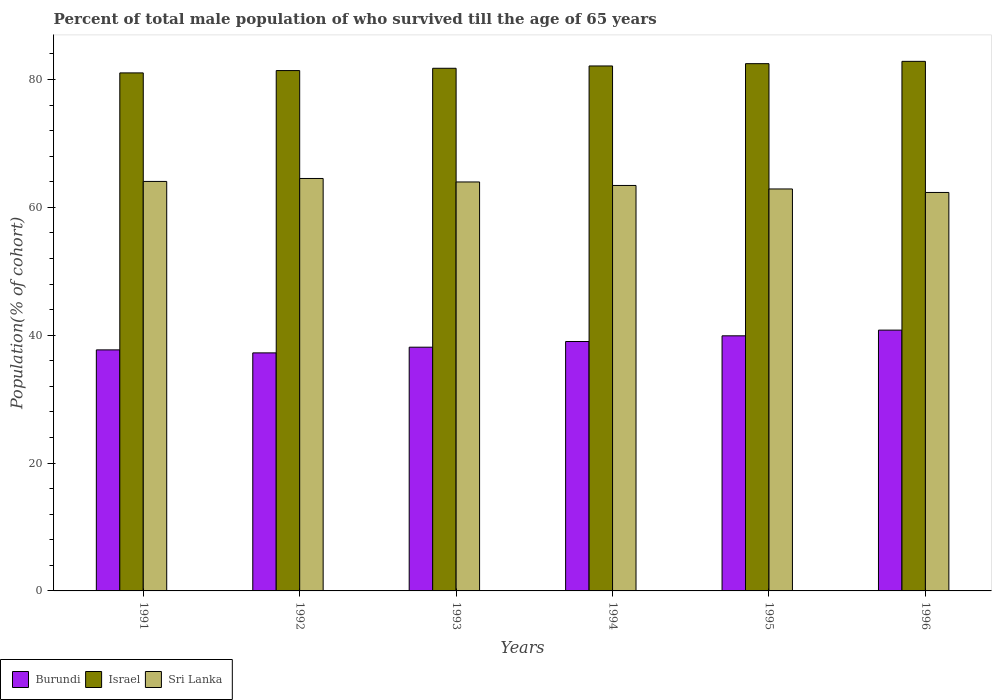How many different coloured bars are there?
Provide a succinct answer. 3. How many groups of bars are there?
Offer a terse response. 6. Are the number of bars per tick equal to the number of legend labels?
Offer a terse response. Yes. How many bars are there on the 4th tick from the left?
Your answer should be very brief. 3. How many bars are there on the 1st tick from the right?
Provide a succinct answer. 3. What is the label of the 1st group of bars from the left?
Keep it short and to the point. 1991. What is the percentage of total male population who survived till the age of 65 years in Israel in 1993?
Give a very brief answer. 81.76. Across all years, what is the maximum percentage of total male population who survived till the age of 65 years in Sri Lanka?
Provide a succinct answer. 64.52. Across all years, what is the minimum percentage of total male population who survived till the age of 65 years in Burundi?
Make the answer very short. 37.24. In which year was the percentage of total male population who survived till the age of 65 years in Israel maximum?
Your answer should be very brief. 1996. What is the total percentage of total male population who survived till the age of 65 years in Sri Lanka in the graph?
Make the answer very short. 381.21. What is the difference between the percentage of total male population who survived till the age of 65 years in Israel in 1993 and that in 1994?
Offer a terse response. -0.36. What is the difference between the percentage of total male population who survived till the age of 65 years in Israel in 1993 and the percentage of total male population who survived till the age of 65 years in Burundi in 1991?
Give a very brief answer. 44.06. What is the average percentage of total male population who survived till the age of 65 years in Israel per year?
Ensure brevity in your answer.  81.94. In the year 1995, what is the difference between the percentage of total male population who survived till the age of 65 years in Israel and percentage of total male population who survived till the age of 65 years in Burundi?
Give a very brief answer. 42.58. What is the ratio of the percentage of total male population who survived till the age of 65 years in Israel in 1995 to that in 1996?
Keep it short and to the point. 1. Is the percentage of total male population who survived till the age of 65 years in Sri Lanka in 1992 less than that in 1994?
Make the answer very short. No. Is the difference between the percentage of total male population who survived till the age of 65 years in Israel in 1991 and 1996 greater than the difference between the percentage of total male population who survived till the age of 65 years in Burundi in 1991 and 1996?
Make the answer very short. Yes. What is the difference between the highest and the second highest percentage of total male population who survived till the age of 65 years in Burundi?
Offer a very short reply. 0.89. What is the difference between the highest and the lowest percentage of total male population who survived till the age of 65 years in Burundi?
Offer a terse response. 3.56. In how many years, is the percentage of total male population who survived till the age of 65 years in Israel greater than the average percentage of total male population who survived till the age of 65 years in Israel taken over all years?
Keep it short and to the point. 3. Is the sum of the percentage of total male population who survived till the age of 65 years in Burundi in 1991 and 1995 greater than the maximum percentage of total male population who survived till the age of 65 years in Sri Lanka across all years?
Your response must be concise. Yes. What does the 1st bar from the left in 1996 represents?
Provide a succinct answer. Burundi. What does the 3rd bar from the right in 1994 represents?
Your answer should be compact. Burundi. Is it the case that in every year, the sum of the percentage of total male population who survived till the age of 65 years in Burundi and percentage of total male population who survived till the age of 65 years in Sri Lanka is greater than the percentage of total male population who survived till the age of 65 years in Israel?
Your response must be concise. Yes. What is the title of the graph?
Keep it short and to the point. Percent of total male population of who survived till the age of 65 years. What is the label or title of the Y-axis?
Your answer should be very brief. Population(% of cohort). What is the Population(% of cohort) of Burundi in 1991?
Keep it short and to the point. 37.71. What is the Population(% of cohort) in Israel in 1991?
Make the answer very short. 81.04. What is the Population(% of cohort) in Sri Lanka in 1991?
Offer a terse response. 64.06. What is the Population(% of cohort) in Burundi in 1992?
Offer a very short reply. 37.24. What is the Population(% of cohort) in Israel in 1992?
Your response must be concise. 81.4. What is the Population(% of cohort) in Sri Lanka in 1992?
Your answer should be compact. 64.52. What is the Population(% of cohort) of Burundi in 1993?
Offer a very short reply. 38.13. What is the Population(% of cohort) of Israel in 1993?
Ensure brevity in your answer.  81.76. What is the Population(% of cohort) in Sri Lanka in 1993?
Ensure brevity in your answer.  63.98. What is the Population(% of cohort) in Burundi in 1994?
Provide a short and direct response. 39.02. What is the Population(% of cohort) in Israel in 1994?
Provide a short and direct response. 82.12. What is the Population(% of cohort) of Sri Lanka in 1994?
Make the answer very short. 63.43. What is the Population(% of cohort) in Burundi in 1995?
Your answer should be compact. 39.91. What is the Population(% of cohort) in Israel in 1995?
Your answer should be very brief. 82.49. What is the Population(% of cohort) in Sri Lanka in 1995?
Provide a short and direct response. 62.88. What is the Population(% of cohort) of Burundi in 1996?
Provide a succinct answer. 40.8. What is the Population(% of cohort) in Israel in 1996?
Offer a terse response. 82.85. What is the Population(% of cohort) in Sri Lanka in 1996?
Your answer should be compact. 62.34. Across all years, what is the maximum Population(% of cohort) of Burundi?
Offer a very short reply. 40.8. Across all years, what is the maximum Population(% of cohort) in Israel?
Your answer should be compact. 82.85. Across all years, what is the maximum Population(% of cohort) of Sri Lanka?
Your response must be concise. 64.52. Across all years, what is the minimum Population(% of cohort) in Burundi?
Your answer should be very brief. 37.24. Across all years, what is the minimum Population(% of cohort) of Israel?
Provide a succinct answer. 81.04. Across all years, what is the minimum Population(% of cohort) of Sri Lanka?
Offer a very short reply. 62.34. What is the total Population(% of cohort) of Burundi in the graph?
Make the answer very short. 232.8. What is the total Population(% of cohort) in Israel in the graph?
Give a very brief answer. 491.66. What is the total Population(% of cohort) of Sri Lanka in the graph?
Your response must be concise. 381.21. What is the difference between the Population(% of cohort) in Burundi in 1991 and that in 1992?
Provide a short and direct response. 0.47. What is the difference between the Population(% of cohort) of Israel in 1991 and that in 1992?
Make the answer very short. -0.36. What is the difference between the Population(% of cohort) in Sri Lanka in 1991 and that in 1992?
Make the answer very short. -0.46. What is the difference between the Population(% of cohort) of Burundi in 1991 and that in 1993?
Offer a terse response. -0.42. What is the difference between the Population(% of cohort) in Israel in 1991 and that in 1993?
Your answer should be compact. -0.72. What is the difference between the Population(% of cohort) of Sri Lanka in 1991 and that in 1993?
Offer a very short reply. 0.08. What is the difference between the Population(% of cohort) of Burundi in 1991 and that in 1994?
Provide a short and direct response. -1.31. What is the difference between the Population(% of cohort) in Israel in 1991 and that in 1994?
Make the answer very short. -1.09. What is the difference between the Population(% of cohort) of Sri Lanka in 1991 and that in 1994?
Provide a short and direct response. 0.63. What is the difference between the Population(% of cohort) of Burundi in 1991 and that in 1995?
Your answer should be very brief. -2.2. What is the difference between the Population(% of cohort) in Israel in 1991 and that in 1995?
Your response must be concise. -1.45. What is the difference between the Population(% of cohort) in Sri Lanka in 1991 and that in 1995?
Provide a succinct answer. 1.18. What is the difference between the Population(% of cohort) in Burundi in 1991 and that in 1996?
Provide a short and direct response. -3.09. What is the difference between the Population(% of cohort) in Israel in 1991 and that in 1996?
Your answer should be very brief. -1.81. What is the difference between the Population(% of cohort) of Sri Lanka in 1991 and that in 1996?
Make the answer very short. 1.73. What is the difference between the Population(% of cohort) in Burundi in 1992 and that in 1993?
Your answer should be compact. -0.89. What is the difference between the Population(% of cohort) of Israel in 1992 and that in 1993?
Provide a short and direct response. -0.36. What is the difference between the Population(% of cohort) of Sri Lanka in 1992 and that in 1993?
Offer a terse response. 0.55. What is the difference between the Population(% of cohort) in Burundi in 1992 and that in 1994?
Keep it short and to the point. -1.78. What is the difference between the Population(% of cohort) in Israel in 1992 and that in 1994?
Your answer should be compact. -0.72. What is the difference between the Population(% of cohort) in Sri Lanka in 1992 and that in 1994?
Offer a very short reply. 1.09. What is the difference between the Population(% of cohort) of Burundi in 1992 and that in 1995?
Ensure brevity in your answer.  -2.67. What is the difference between the Population(% of cohort) in Israel in 1992 and that in 1995?
Offer a terse response. -1.08. What is the difference between the Population(% of cohort) in Sri Lanka in 1992 and that in 1995?
Give a very brief answer. 1.64. What is the difference between the Population(% of cohort) in Burundi in 1992 and that in 1996?
Offer a terse response. -3.56. What is the difference between the Population(% of cohort) of Israel in 1992 and that in 1996?
Make the answer very short. -1.44. What is the difference between the Population(% of cohort) in Sri Lanka in 1992 and that in 1996?
Provide a short and direct response. 2.19. What is the difference between the Population(% of cohort) in Burundi in 1993 and that in 1994?
Give a very brief answer. -0.89. What is the difference between the Population(% of cohort) of Israel in 1993 and that in 1994?
Your answer should be very brief. -0.36. What is the difference between the Population(% of cohort) in Sri Lanka in 1993 and that in 1994?
Provide a succinct answer. 0.55. What is the difference between the Population(% of cohort) in Burundi in 1993 and that in 1995?
Your answer should be compact. -1.78. What is the difference between the Population(% of cohort) of Israel in 1993 and that in 1995?
Keep it short and to the point. -0.72. What is the difference between the Population(% of cohort) of Sri Lanka in 1993 and that in 1995?
Provide a succinct answer. 1.09. What is the difference between the Population(% of cohort) of Burundi in 1993 and that in 1996?
Ensure brevity in your answer.  -2.67. What is the difference between the Population(% of cohort) of Israel in 1993 and that in 1996?
Offer a very short reply. -1.08. What is the difference between the Population(% of cohort) in Sri Lanka in 1993 and that in 1996?
Ensure brevity in your answer.  1.64. What is the difference between the Population(% of cohort) in Burundi in 1994 and that in 1995?
Make the answer very short. -0.89. What is the difference between the Population(% of cohort) of Israel in 1994 and that in 1995?
Your answer should be compact. -0.36. What is the difference between the Population(% of cohort) in Sri Lanka in 1994 and that in 1995?
Provide a short and direct response. 0.55. What is the difference between the Population(% of cohort) in Burundi in 1994 and that in 1996?
Offer a terse response. -1.78. What is the difference between the Population(% of cohort) in Israel in 1994 and that in 1996?
Make the answer very short. -0.72. What is the difference between the Population(% of cohort) of Sri Lanka in 1994 and that in 1996?
Make the answer very short. 1.09. What is the difference between the Population(% of cohort) in Burundi in 1995 and that in 1996?
Offer a terse response. -0.89. What is the difference between the Population(% of cohort) of Israel in 1995 and that in 1996?
Give a very brief answer. -0.36. What is the difference between the Population(% of cohort) of Sri Lanka in 1995 and that in 1996?
Keep it short and to the point. 0.55. What is the difference between the Population(% of cohort) of Burundi in 1991 and the Population(% of cohort) of Israel in 1992?
Provide a short and direct response. -43.69. What is the difference between the Population(% of cohort) of Burundi in 1991 and the Population(% of cohort) of Sri Lanka in 1992?
Your answer should be very brief. -26.82. What is the difference between the Population(% of cohort) in Israel in 1991 and the Population(% of cohort) in Sri Lanka in 1992?
Your answer should be compact. 16.52. What is the difference between the Population(% of cohort) in Burundi in 1991 and the Population(% of cohort) in Israel in 1993?
Offer a very short reply. -44.06. What is the difference between the Population(% of cohort) of Burundi in 1991 and the Population(% of cohort) of Sri Lanka in 1993?
Make the answer very short. -26.27. What is the difference between the Population(% of cohort) in Israel in 1991 and the Population(% of cohort) in Sri Lanka in 1993?
Ensure brevity in your answer.  17.06. What is the difference between the Population(% of cohort) in Burundi in 1991 and the Population(% of cohort) in Israel in 1994?
Make the answer very short. -44.42. What is the difference between the Population(% of cohort) in Burundi in 1991 and the Population(% of cohort) in Sri Lanka in 1994?
Keep it short and to the point. -25.72. What is the difference between the Population(% of cohort) of Israel in 1991 and the Population(% of cohort) of Sri Lanka in 1994?
Give a very brief answer. 17.61. What is the difference between the Population(% of cohort) in Burundi in 1991 and the Population(% of cohort) in Israel in 1995?
Offer a terse response. -44.78. What is the difference between the Population(% of cohort) of Burundi in 1991 and the Population(% of cohort) of Sri Lanka in 1995?
Give a very brief answer. -25.17. What is the difference between the Population(% of cohort) of Israel in 1991 and the Population(% of cohort) of Sri Lanka in 1995?
Provide a short and direct response. 18.16. What is the difference between the Population(% of cohort) of Burundi in 1991 and the Population(% of cohort) of Israel in 1996?
Ensure brevity in your answer.  -45.14. What is the difference between the Population(% of cohort) of Burundi in 1991 and the Population(% of cohort) of Sri Lanka in 1996?
Your response must be concise. -24.63. What is the difference between the Population(% of cohort) in Israel in 1991 and the Population(% of cohort) in Sri Lanka in 1996?
Give a very brief answer. 18.7. What is the difference between the Population(% of cohort) in Burundi in 1992 and the Population(% of cohort) in Israel in 1993?
Your answer should be very brief. -44.53. What is the difference between the Population(% of cohort) in Burundi in 1992 and the Population(% of cohort) in Sri Lanka in 1993?
Offer a very short reply. -26.74. What is the difference between the Population(% of cohort) in Israel in 1992 and the Population(% of cohort) in Sri Lanka in 1993?
Keep it short and to the point. 17.43. What is the difference between the Population(% of cohort) in Burundi in 1992 and the Population(% of cohort) in Israel in 1994?
Ensure brevity in your answer.  -44.89. What is the difference between the Population(% of cohort) in Burundi in 1992 and the Population(% of cohort) in Sri Lanka in 1994?
Offer a very short reply. -26.19. What is the difference between the Population(% of cohort) in Israel in 1992 and the Population(% of cohort) in Sri Lanka in 1994?
Provide a short and direct response. 17.97. What is the difference between the Population(% of cohort) of Burundi in 1992 and the Population(% of cohort) of Israel in 1995?
Provide a short and direct response. -45.25. What is the difference between the Population(% of cohort) of Burundi in 1992 and the Population(% of cohort) of Sri Lanka in 1995?
Provide a succinct answer. -25.64. What is the difference between the Population(% of cohort) of Israel in 1992 and the Population(% of cohort) of Sri Lanka in 1995?
Your response must be concise. 18.52. What is the difference between the Population(% of cohort) in Burundi in 1992 and the Population(% of cohort) in Israel in 1996?
Keep it short and to the point. -45.61. What is the difference between the Population(% of cohort) of Burundi in 1992 and the Population(% of cohort) of Sri Lanka in 1996?
Make the answer very short. -25.1. What is the difference between the Population(% of cohort) of Israel in 1992 and the Population(% of cohort) of Sri Lanka in 1996?
Ensure brevity in your answer.  19.07. What is the difference between the Population(% of cohort) in Burundi in 1993 and the Population(% of cohort) in Israel in 1994?
Keep it short and to the point. -44. What is the difference between the Population(% of cohort) in Burundi in 1993 and the Population(% of cohort) in Sri Lanka in 1994?
Provide a succinct answer. -25.3. What is the difference between the Population(% of cohort) in Israel in 1993 and the Population(% of cohort) in Sri Lanka in 1994?
Provide a succinct answer. 18.33. What is the difference between the Population(% of cohort) of Burundi in 1993 and the Population(% of cohort) of Israel in 1995?
Keep it short and to the point. -44.36. What is the difference between the Population(% of cohort) of Burundi in 1993 and the Population(% of cohort) of Sri Lanka in 1995?
Your answer should be very brief. -24.75. What is the difference between the Population(% of cohort) of Israel in 1993 and the Population(% of cohort) of Sri Lanka in 1995?
Make the answer very short. 18.88. What is the difference between the Population(% of cohort) of Burundi in 1993 and the Population(% of cohort) of Israel in 1996?
Keep it short and to the point. -44.72. What is the difference between the Population(% of cohort) in Burundi in 1993 and the Population(% of cohort) in Sri Lanka in 1996?
Make the answer very short. -24.21. What is the difference between the Population(% of cohort) in Israel in 1993 and the Population(% of cohort) in Sri Lanka in 1996?
Give a very brief answer. 19.43. What is the difference between the Population(% of cohort) of Burundi in 1994 and the Population(% of cohort) of Israel in 1995?
Keep it short and to the point. -43.47. What is the difference between the Population(% of cohort) of Burundi in 1994 and the Population(% of cohort) of Sri Lanka in 1995?
Provide a succinct answer. -23.86. What is the difference between the Population(% of cohort) of Israel in 1994 and the Population(% of cohort) of Sri Lanka in 1995?
Ensure brevity in your answer.  19.24. What is the difference between the Population(% of cohort) in Burundi in 1994 and the Population(% of cohort) in Israel in 1996?
Give a very brief answer. -43.83. What is the difference between the Population(% of cohort) in Burundi in 1994 and the Population(% of cohort) in Sri Lanka in 1996?
Provide a succinct answer. -23.32. What is the difference between the Population(% of cohort) in Israel in 1994 and the Population(% of cohort) in Sri Lanka in 1996?
Offer a terse response. 19.79. What is the difference between the Population(% of cohort) in Burundi in 1995 and the Population(% of cohort) in Israel in 1996?
Make the answer very short. -42.94. What is the difference between the Population(% of cohort) of Burundi in 1995 and the Population(% of cohort) of Sri Lanka in 1996?
Provide a short and direct response. -22.43. What is the difference between the Population(% of cohort) of Israel in 1995 and the Population(% of cohort) of Sri Lanka in 1996?
Provide a succinct answer. 20.15. What is the average Population(% of cohort) in Burundi per year?
Provide a succinct answer. 38.8. What is the average Population(% of cohort) in Israel per year?
Provide a short and direct response. 81.94. What is the average Population(% of cohort) in Sri Lanka per year?
Offer a terse response. 63.54. In the year 1991, what is the difference between the Population(% of cohort) of Burundi and Population(% of cohort) of Israel?
Keep it short and to the point. -43.33. In the year 1991, what is the difference between the Population(% of cohort) in Burundi and Population(% of cohort) in Sri Lanka?
Provide a succinct answer. -26.35. In the year 1991, what is the difference between the Population(% of cohort) in Israel and Population(% of cohort) in Sri Lanka?
Ensure brevity in your answer.  16.98. In the year 1992, what is the difference between the Population(% of cohort) of Burundi and Population(% of cohort) of Israel?
Offer a very short reply. -44.17. In the year 1992, what is the difference between the Population(% of cohort) in Burundi and Population(% of cohort) in Sri Lanka?
Provide a succinct answer. -27.29. In the year 1992, what is the difference between the Population(% of cohort) of Israel and Population(% of cohort) of Sri Lanka?
Provide a short and direct response. 16.88. In the year 1993, what is the difference between the Population(% of cohort) of Burundi and Population(% of cohort) of Israel?
Your answer should be very brief. -43.64. In the year 1993, what is the difference between the Population(% of cohort) of Burundi and Population(% of cohort) of Sri Lanka?
Keep it short and to the point. -25.85. In the year 1993, what is the difference between the Population(% of cohort) of Israel and Population(% of cohort) of Sri Lanka?
Ensure brevity in your answer.  17.79. In the year 1994, what is the difference between the Population(% of cohort) of Burundi and Population(% of cohort) of Israel?
Ensure brevity in your answer.  -43.11. In the year 1994, what is the difference between the Population(% of cohort) in Burundi and Population(% of cohort) in Sri Lanka?
Your response must be concise. -24.41. In the year 1994, what is the difference between the Population(% of cohort) in Israel and Population(% of cohort) in Sri Lanka?
Keep it short and to the point. 18.69. In the year 1995, what is the difference between the Population(% of cohort) of Burundi and Population(% of cohort) of Israel?
Offer a terse response. -42.58. In the year 1995, what is the difference between the Population(% of cohort) in Burundi and Population(% of cohort) in Sri Lanka?
Provide a short and direct response. -22.97. In the year 1995, what is the difference between the Population(% of cohort) in Israel and Population(% of cohort) in Sri Lanka?
Ensure brevity in your answer.  19.6. In the year 1996, what is the difference between the Population(% of cohort) in Burundi and Population(% of cohort) in Israel?
Provide a short and direct response. -42.05. In the year 1996, what is the difference between the Population(% of cohort) of Burundi and Population(% of cohort) of Sri Lanka?
Give a very brief answer. -21.54. In the year 1996, what is the difference between the Population(% of cohort) of Israel and Population(% of cohort) of Sri Lanka?
Your response must be concise. 20.51. What is the ratio of the Population(% of cohort) in Burundi in 1991 to that in 1992?
Your answer should be very brief. 1.01. What is the ratio of the Population(% of cohort) in Israel in 1991 to that in 1992?
Give a very brief answer. 1. What is the ratio of the Population(% of cohort) in Burundi in 1991 to that in 1993?
Offer a terse response. 0.99. What is the ratio of the Population(% of cohort) of Israel in 1991 to that in 1993?
Make the answer very short. 0.99. What is the ratio of the Population(% of cohort) in Burundi in 1991 to that in 1994?
Offer a very short reply. 0.97. What is the ratio of the Population(% of cohort) in Burundi in 1991 to that in 1995?
Your answer should be compact. 0.94. What is the ratio of the Population(% of cohort) in Israel in 1991 to that in 1995?
Keep it short and to the point. 0.98. What is the ratio of the Population(% of cohort) in Sri Lanka in 1991 to that in 1995?
Your response must be concise. 1.02. What is the ratio of the Population(% of cohort) of Burundi in 1991 to that in 1996?
Provide a short and direct response. 0.92. What is the ratio of the Population(% of cohort) of Israel in 1991 to that in 1996?
Give a very brief answer. 0.98. What is the ratio of the Population(% of cohort) of Sri Lanka in 1991 to that in 1996?
Your answer should be compact. 1.03. What is the ratio of the Population(% of cohort) in Burundi in 1992 to that in 1993?
Make the answer very short. 0.98. What is the ratio of the Population(% of cohort) in Sri Lanka in 1992 to that in 1993?
Offer a very short reply. 1.01. What is the ratio of the Population(% of cohort) of Burundi in 1992 to that in 1994?
Make the answer very short. 0.95. What is the ratio of the Population(% of cohort) in Israel in 1992 to that in 1994?
Your response must be concise. 0.99. What is the ratio of the Population(% of cohort) of Sri Lanka in 1992 to that in 1994?
Your answer should be very brief. 1.02. What is the ratio of the Population(% of cohort) of Burundi in 1992 to that in 1995?
Your answer should be compact. 0.93. What is the ratio of the Population(% of cohort) of Israel in 1992 to that in 1995?
Provide a short and direct response. 0.99. What is the ratio of the Population(% of cohort) of Sri Lanka in 1992 to that in 1995?
Ensure brevity in your answer.  1.03. What is the ratio of the Population(% of cohort) in Burundi in 1992 to that in 1996?
Your response must be concise. 0.91. What is the ratio of the Population(% of cohort) in Israel in 1992 to that in 1996?
Offer a very short reply. 0.98. What is the ratio of the Population(% of cohort) of Sri Lanka in 1992 to that in 1996?
Keep it short and to the point. 1.04. What is the ratio of the Population(% of cohort) of Burundi in 1993 to that in 1994?
Your answer should be very brief. 0.98. What is the ratio of the Population(% of cohort) of Israel in 1993 to that in 1994?
Provide a succinct answer. 1. What is the ratio of the Population(% of cohort) in Sri Lanka in 1993 to that in 1994?
Ensure brevity in your answer.  1.01. What is the ratio of the Population(% of cohort) in Burundi in 1993 to that in 1995?
Keep it short and to the point. 0.96. What is the ratio of the Population(% of cohort) in Israel in 1993 to that in 1995?
Ensure brevity in your answer.  0.99. What is the ratio of the Population(% of cohort) of Sri Lanka in 1993 to that in 1995?
Give a very brief answer. 1.02. What is the ratio of the Population(% of cohort) in Burundi in 1993 to that in 1996?
Offer a very short reply. 0.93. What is the ratio of the Population(% of cohort) of Israel in 1993 to that in 1996?
Give a very brief answer. 0.99. What is the ratio of the Population(% of cohort) of Sri Lanka in 1993 to that in 1996?
Ensure brevity in your answer.  1.03. What is the ratio of the Population(% of cohort) of Burundi in 1994 to that in 1995?
Make the answer very short. 0.98. What is the ratio of the Population(% of cohort) of Sri Lanka in 1994 to that in 1995?
Provide a short and direct response. 1.01. What is the ratio of the Population(% of cohort) in Burundi in 1994 to that in 1996?
Offer a terse response. 0.96. What is the ratio of the Population(% of cohort) of Israel in 1994 to that in 1996?
Your response must be concise. 0.99. What is the ratio of the Population(% of cohort) of Sri Lanka in 1994 to that in 1996?
Ensure brevity in your answer.  1.02. What is the ratio of the Population(% of cohort) in Burundi in 1995 to that in 1996?
Your answer should be compact. 0.98. What is the ratio of the Population(% of cohort) of Israel in 1995 to that in 1996?
Offer a terse response. 1. What is the ratio of the Population(% of cohort) in Sri Lanka in 1995 to that in 1996?
Make the answer very short. 1.01. What is the difference between the highest and the second highest Population(% of cohort) of Burundi?
Your answer should be compact. 0.89. What is the difference between the highest and the second highest Population(% of cohort) in Israel?
Ensure brevity in your answer.  0.36. What is the difference between the highest and the second highest Population(% of cohort) of Sri Lanka?
Provide a succinct answer. 0.46. What is the difference between the highest and the lowest Population(% of cohort) of Burundi?
Provide a short and direct response. 3.56. What is the difference between the highest and the lowest Population(% of cohort) of Israel?
Keep it short and to the point. 1.81. What is the difference between the highest and the lowest Population(% of cohort) of Sri Lanka?
Provide a succinct answer. 2.19. 